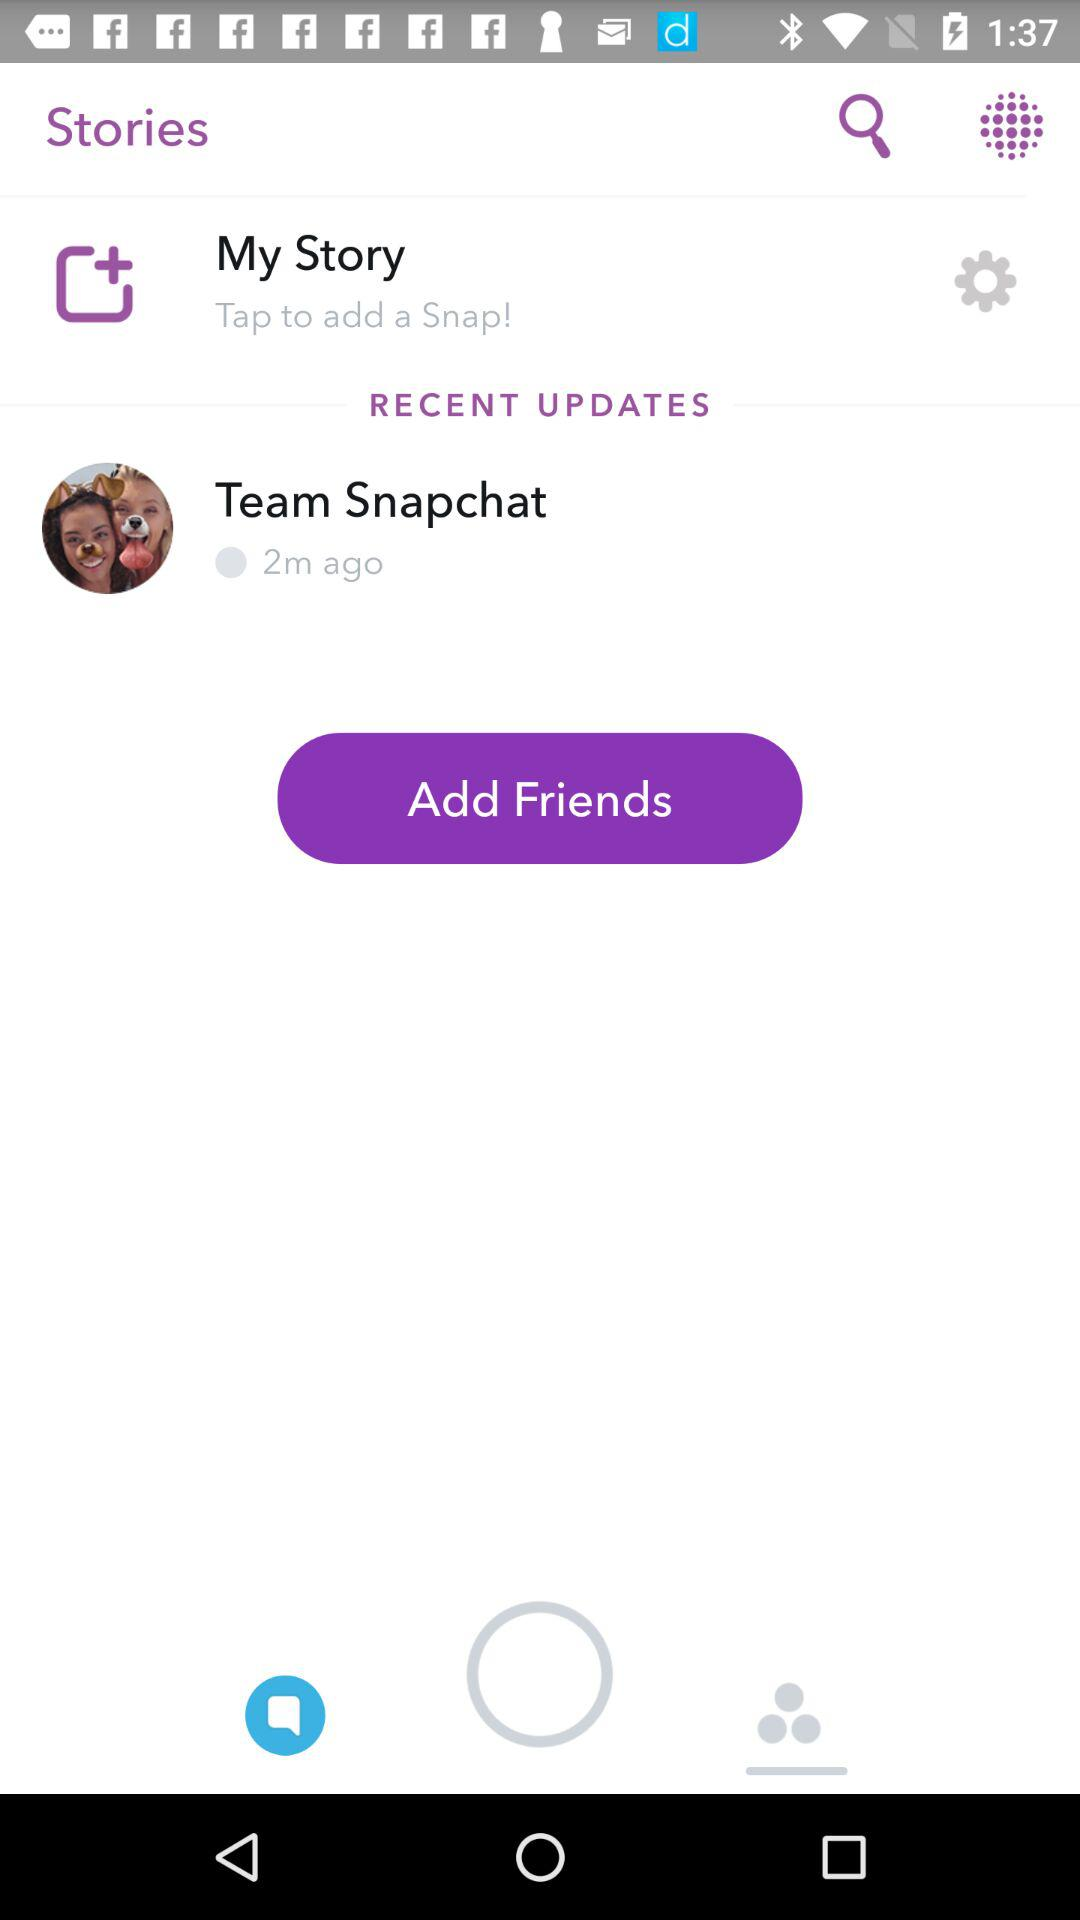What is the availability status of "Team Snapchat"? The availability status of "Team Snapchat" is "Away". 